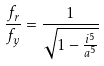Convert formula to latex. <formula><loc_0><loc_0><loc_500><loc_500>\frac { f _ { r } } { f _ { y } } = \frac { 1 } { \sqrt { 1 - \frac { i ^ { 5 } } { a ^ { 5 } } } }</formula> 